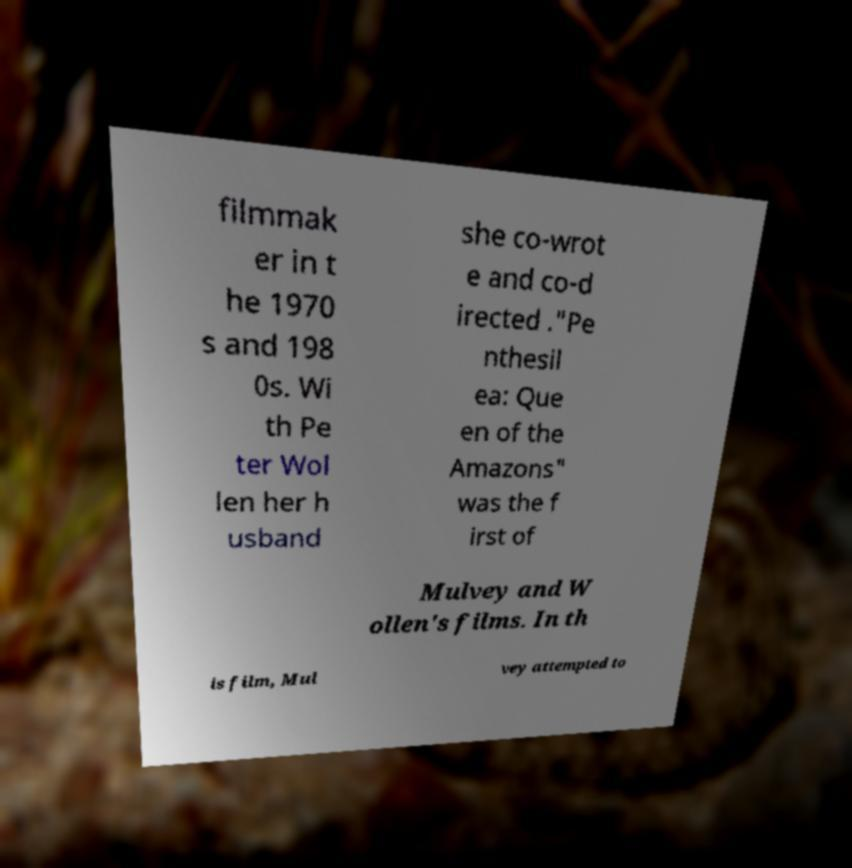Could you extract and type out the text from this image? filmmak er in t he 1970 s and 198 0s. Wi th Pe ter Wol len her h usband she co-wrot e and co-d irected ."Pe nthesil ea: Que en of the Amazons" was the f irst of Mulvey and W ollen's films. In th is film, Mul vey attempted to 